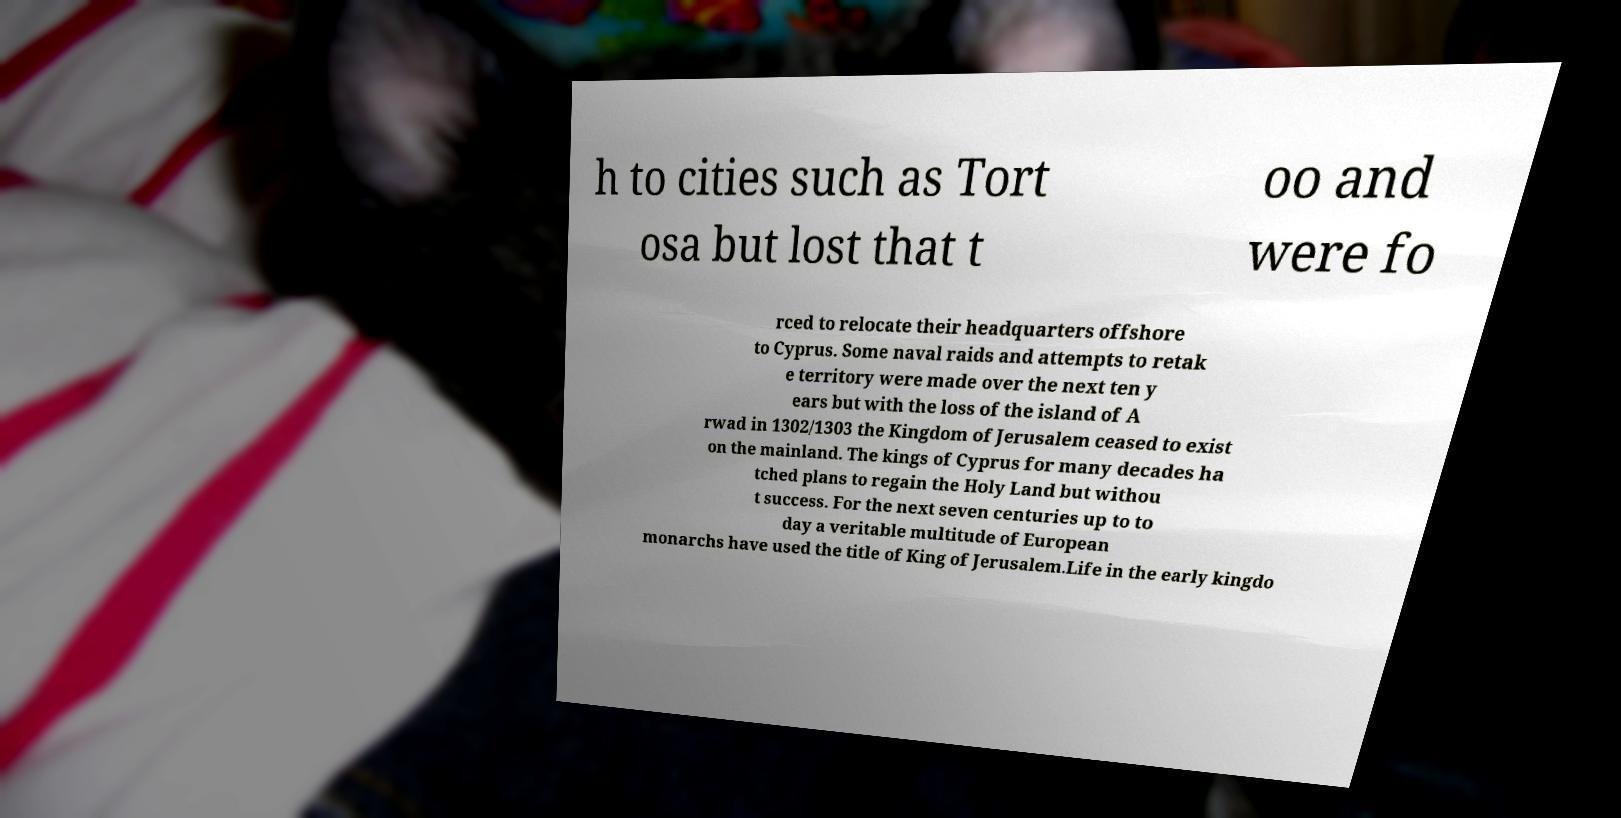Please identify and transcribe the text found in this image. h to cities such as Tort osa but lost that t oo and were fo rced to relocate their headquarters offshore to Cyprus. Some naval raids and attempts to retak e territory were made over the next ten y ears but with the loss of the island of A rwad in 1302/1303 the Kingdom of Jerusalem ceased to exist on the mainland. The kings of Cyprus for many decades ha tched plans to regain the Holy Land but withou t success. For the next seven centuries up to to day a veritable multitude of European monarchs have used the title of King of Jerusalem.Life in the early kingdo 